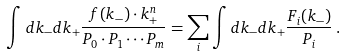Convert formula to latex. <formula><loc_0><loc_0><loc_500><loc_500>\int d k _ { - } d k _ { + } \frac { f ( k _ { - } ) \cdot k _ { + } ^ { n } } { P _ { 0 } \cdot P _ { 1 } \cdots P _ { m } } = \sum _ { i } \int d k _ { - } d k _ { + } \frac { F _ { i } ( k _ { - } ) } { P _ { i } } \, .</formula> 